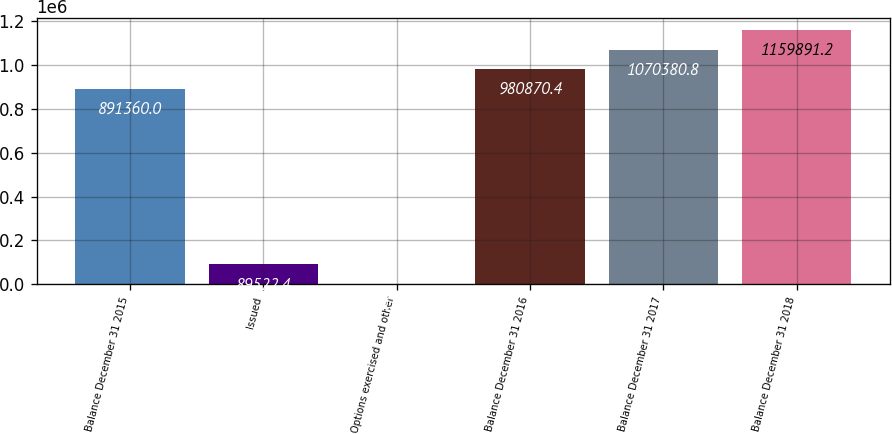Convert chart. <chart><loc_0><loc_0><loc_500><loc_500><bar_chart><fcel>Balance December 31 2015<fcel>Issued<fcel>Options exercised and other<fcel>Balance December 31 2016<fcel>Balance December 31 2017<fcel>Balance December 31 2018<nl><fcel>891360<fcel>89522.4<fcel>12<fcel>980870<fcel>1.07038e+06<fcel>1.15989e+06<nl></chart> 